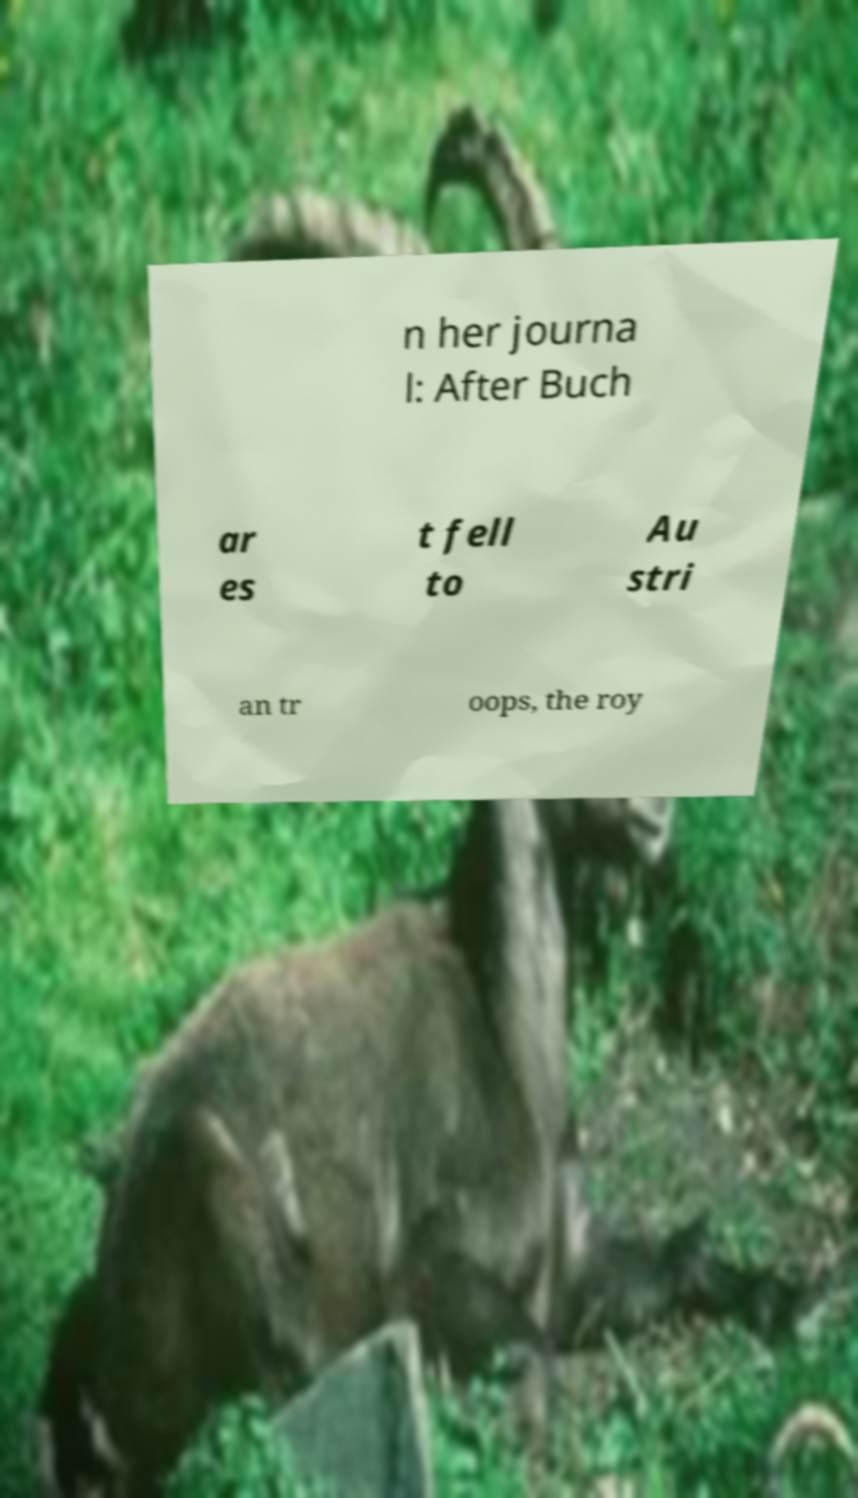Please read and relay the text visible in this image. What does it say? n her journa l: After Buch ar es t fell to Au stri an tr oops, the roy 